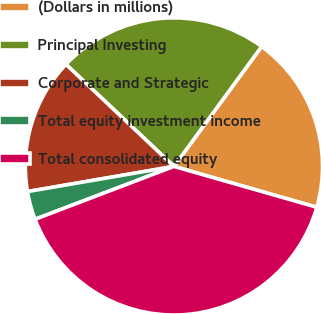Convert chart to OTSL. <chart><loc_0><loc_0><loc_500><loc_500><pie_chart><fcel>(Dollars in millions)<fcel>Principal Investing<fcel>Corporate and Strategic<fcel>Total equity investment income<fcel>Total consolidated equity<nl><fcel>19.38%<fcel>23.0%<fcel>14.76%<fcel>3.08%<fcel>39.78%<nl></chart> 